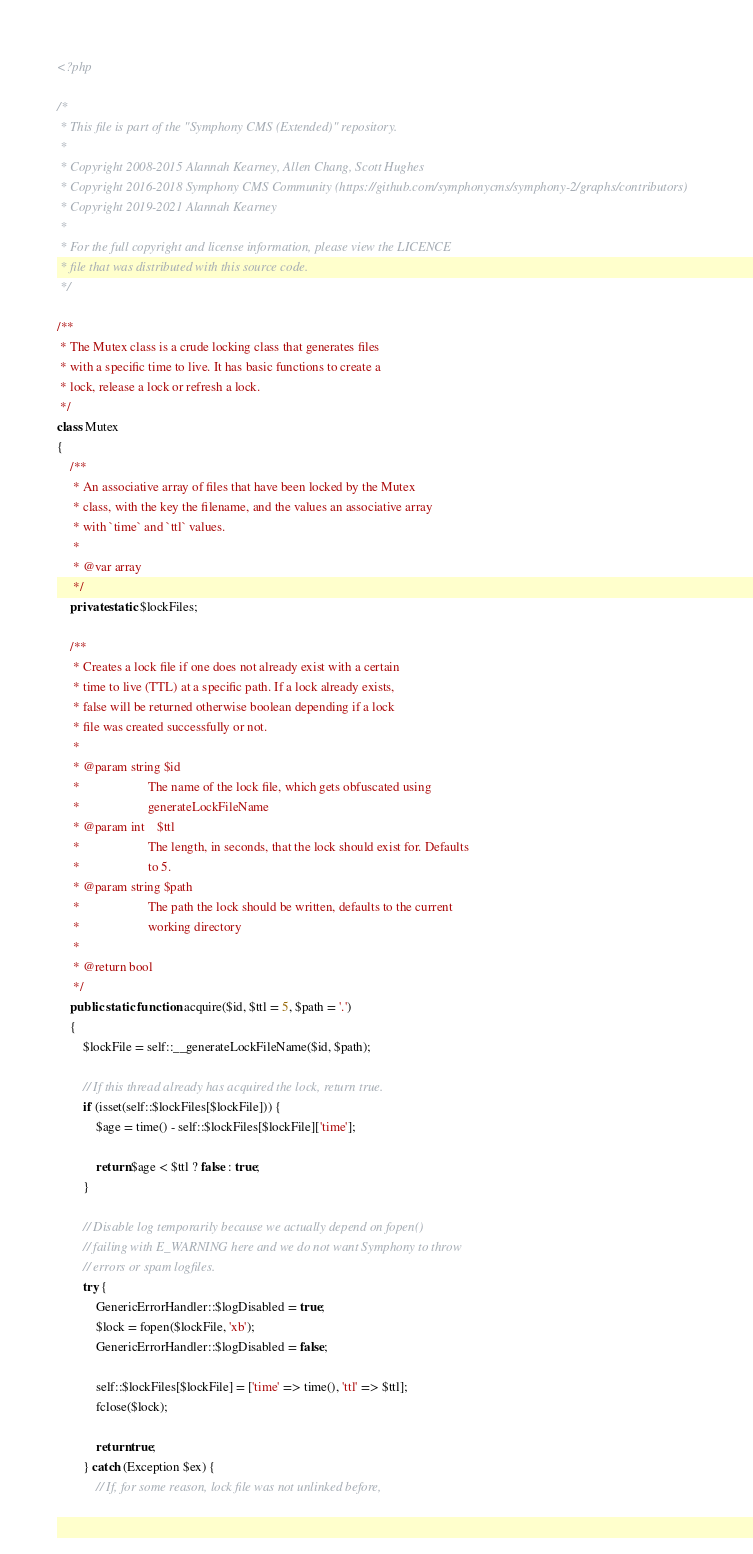Convert code to text. <code><loc_0><loc_0><loc_500><loc_500><_PHP_><?php

/*
 * This file is part of the "Symphony CMS (Extended)" repository.
 *
 * Copyright 2008-2015 Alannah Kearney, Allen Chang, Scott Hughes
 * Copyright 2016-2018 Symphony CMS Community (https://github.com/symphonycms/symphony-2/graphs/contributors)
 * Copyright 2019-2021 Alannah Kearney
 *
 * For the full copyright and license information, please view the LICENCE
 * file that was distributed with this source code.
 */

/**
 * The Mutex class is a crude locking class that generates files
 * with a specific time to live. It has basic functions to create a
 * lock, release a lock or refresh a lock.
 */
class Mutex
{
    /**
     * An associative array of files that have been locked by the Mutex
     * class, with the key the filename, and the values an associative array
     * with `time` and `ttl` values.
     *
     * @var array
     */
    private static $lockFiles;

    /**
     * Creates a lock file if one does not already exist with a certain
     * time to live (TTL) at a specific path. If a lock already exists,
     * false will be returned otherwise boolean depending if a lock
     * file was created successfully or not.
     *
     * @param string $id
     *                     The name of the lock file, which gets obfuscated using
     *                     generateLockFileName
     * @param int    $ttl
     *                     The length, in seconds, that the lock should exist for. Defaults
     *                     to 5.
     * @param string $path
     *                     The path the lock should be written, defaults to the current
     *                     working directory
     *
     * @return bool
     */
    public static function acquire($id, $ttl = 5, $path = '.')
    {
        $lockFile = self::__generateLockFileName($id, $path);

        // If this thread already has acquired the lock, return true.
        if (isset(self::$lockFiles[$lockFile])) {
            $age = time() - self::$lockFiles[$lockFile]['time'];

            return $age < $ttl ? false : true;
        }

        // Disable log temporarily because we actually depend on fopen()
        // failing with E_WARNING here and we do not want Symphony to throw
        // errors or spam logfiles.
        try {
            GenericErrorHandler::$logDisabled = true;
            $lock = fopen($lockFile, 'xb');
            GenericErrorHandler::$logDisabled = false;

            self::$lockFiles[$lockFile] = ['time' => time(), 'ttl' => $ttl];
            fclose($lock);

            return true;
        } catch (Exception $ex) {
            // If, for some reason, lock file was not unlinked before,</code> 